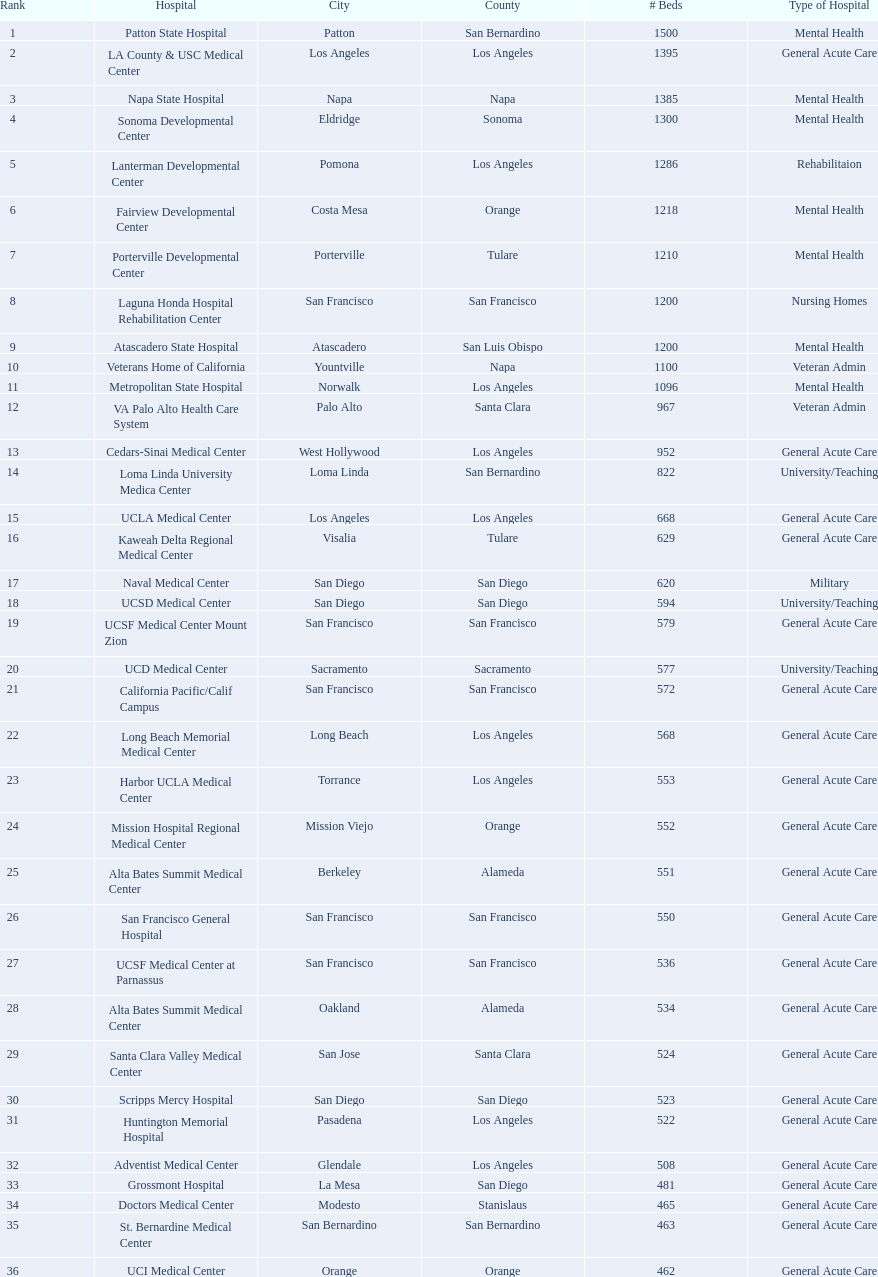In terms of mental health hospital beds, is patton state hospital in san bernardino county larger than atascadero state hospital in san luis obispo county? Yes. 